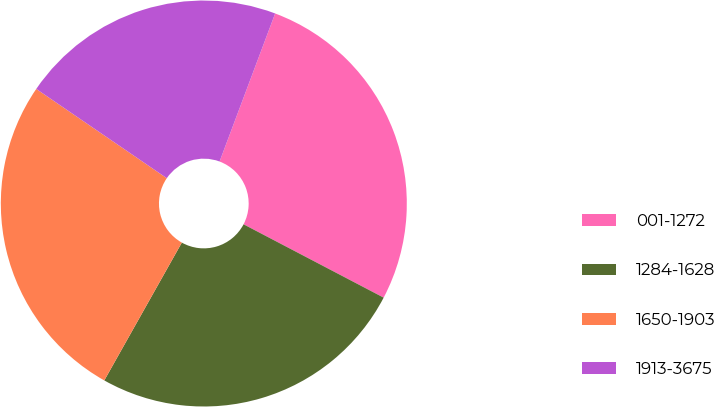<chart> <loc_0><loc_0><loc_500><loc_500><pie_chart><fcel>001-1272<fcel>1284-1628<fcel>1650-1903<fcel>1913-3675<nl><fcel>26.96%<fcel>25.48%<fcel>26.39%<fcel>21.17%<nl></chart> 